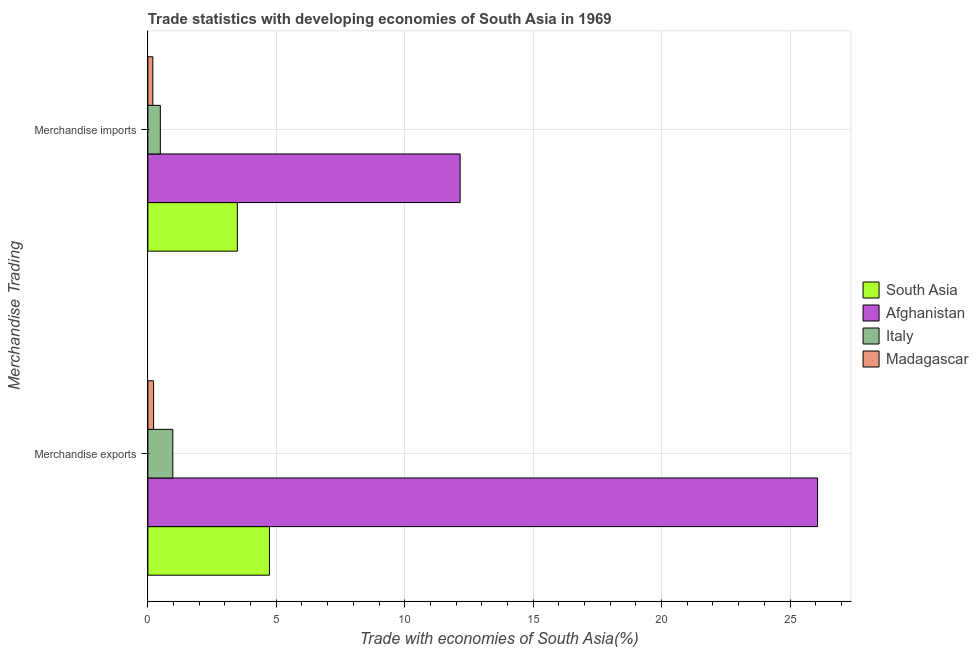How many groups of bars are there?
Your answer should be very brief. 2. Are the number of bars on each tick of the Y-axis equal?
Make the answer very short. Yes. What is the label of the 2nd group of bars from the top?
Offer a very short reply. Merchandise exports. What is the merchandise exports in Madagascar?
Give a very brief answer. 0.22. Across all countries, what is the maximum merchandise imports?
Provide a short and direct response. 12.16. Across all countries, what is the minimum merchandise exports?
Provide a short and direct response. 0.22. In which country was the merchandise imports maximum?
Offer a terse response. Afghanistan. In which country was the merchandise exports minimum?
Keep it short and to the point. Madagascar. What is the total merchandise imports in the graph?
Offer a terse response. 16.32. What is the difference between the merchandise exports in Afghanistan and that in Italy?
Provide a short and direct response. 25.1. What is the difference between the merchandise imports in Italy and the merchandise exports in South Asia?
Give a very brief answer. -4.25. What is the average merchandise exports per country?
Ensure brevity in your answer.  8. What is the difference between the merchandise exports and merchandise imports in Italy?
Keep it short and to the point. 0.49. In how many countries, is the merchandise exports greater than 2 %?
Make the answer very short. 2. What is the ratio of the merchandise imports in South Asia to that in Afghanistan?
Your answer should be very brief. 0.29. In how many countries, is the merchandise imports greater than the average merchandise imports taken over all countries?
Ensure brevity in your answer.  1. How many countries are there in the graph?
Your answer should be very brief. 4. Are the values on the major ticks of X-axis written in scientific E-notation?
Offer a terse response. No. Does the graph contain any zero values?
Offer a very short reply. No. Does the graph contain grids?
Your answer should be compact. Yes. How many legend labels are there?
Make the answer very short. 4. What is the title of the graph?
Offer a very short reply. Trade statistics with developing economies of South Asia in 1969. Does "Cabo Verde" appear as one of the legend labels in the graph?
Provide a succinct answer. No. What is the label or title of the X-axis?
Your answer should be compact. Trade with economies of South Asia(%). What is the label or title of the Y-axis?
Your answer should be compact. Merchandise Trading. What is the Trade with economies of South Asia(%) in South Asia in Merchandise exports?
Your answer should be compact. 4.73. What is the Trade with economies of South Asia(%) of Afghanistan in Merchandise exports?
Provide a succinct answer. 26.07. What is the Trade with economies of South Asia(%) of Italy in Merchandise exports?
Offer a very short reply. 0.97. What is the Trade with economies of South Asia(%) in Madagascar in Merchandise exports?
Keep it short and to the point. 0.22. What is the Trade with economies of South Asia(%) of South Asia in Merchandise imports?
Your response must be concise. 3.48. What is the Trade with economies of South Asia(%) of Afghanistan in Merchandise imports?
Make the answer very short. 12.16. What is the Trade with economies of South Asia(%) in Italy in Merchandise imports?
Ensure brevity in your answer.  0.48. What is the Trade with economies of South Asia(%) in Madagascar in Merchandise imports?
Make the answer very short. 0.19. Across all Merchandise Trading, what is the maximum Trade with economies of South Asia(%) in South Asia?
Give a very brief answer. 4.73. Across all Merchandise Trading, what is the maximum Trade with economies of South Asia(%) in Afghanistan?
Ensure brevity in your answer.  26.07. Across all Merchandise Trading, what is the maximum Trade with economies of South Asia(%) of Italy?
Ensure brevity in your answer.  0.97. Across all Merchandise Trading, what is the maximum Trade with economies of South Asia(%) of Madagascar?
Offer a very short reply. 0.22. Across all Merchandise Trading, what is the minimum Trade with economies of South Asia(%) of South Asia?
Keep it short and to the point. 3.48. Across all Merchandise Trading, what is the minimum Trade with economies of South Asia(%) of Afghanistan?
Offer a terse response. 12.16. Across all Merchandise Trading, what is the minimum Trade with economies of South Asia(%) in Italy?
Make the answer very short. 0.48. Across all Merchandise Trading, what is the minimum Trade with economies of South Asia(%) of Madagascar?
Your answer should be compact. 0.19. What is the total Trade with economies of South Asia(%) in South Asia in the graph?
Provide a succinct answer. 8.22. What is the total Trade with economies of South Asia(%) of Afghanistan in the graph?
Offer a very short reply. 38.23. What is the total Trade with economies of South Asia(%) in Italy in the graph?
Provide a short and direct response. 1.46. What is the total Trade with economies of South Asia(%) in Madagascar in the graph?
Provide a short and direct response. 0.42. What is the difference between the Trade with economies of South Asia(%) in South Asia in Merchandise exports and that in Merchandise imports?
Keep it short and to the point. 1.25. What is the difference between the Trade with economies of South Asia(%) of Afghanistan in Merchandise exports and that in Merchandise imports?
Offer a terse response. 13.92. What is the difference between the Trade with economies of South Asia(%) of Italy in Merchandise exports and that in Merchandise imports?
Your answer should be very brief. 0.49. What is the difference between the Trade with economies of South Asia(%) in Madagascar in Merchandise exports and that in Merchandise imports?
Offer a terse response. 0.03. What is the difference between the Trade with economies of South Asia(%) in South Asia in Merchandise exports and the Trade with economies of South Asia(%) in Afghanistan in Merchandise imports?
Your response must be concise. -7.42. What is the difference between the Trade with economies of South Asia(%) of South Asia in Merchandise exports and the Trade with economies of South Asia(%) of Italy in Merchandise imports?
Your answer should be very brief. 4.25. What is the difference between the Trade with economies of South Asia(%) of South Asia in Merchandise exports and the Trade with economies of South Asia(%) of Madagascar in Merchandise imports?
Keep it short and to the point. 4.54. What is the difference between the Trade with economies of South Asia(%) in Afghanistan in Merchandise exports and the Trade with economies of South Asia(%) in Italy in Merchandise imports?
Make the answer very short. 25.59. What is the difference between the Trade with economies of South Asia(%) of Afghanistan in Merchandise exports and the Trade with economies of South Asia(%) of Madagascar in Merchandise imports?
Offer a very short reply. 25.88. What is the difference between the Trade with economies of South Asia(%) in Italy in Merchandise exports and the Trade with economies of South Asia(%) in Madagascar in Merchandise imports?
Your response must be concise. 0.78. What is the average Trade with economies of South Asia(%) of South Asia per Merchandise Trading?
Ensure brevity in your answer.  4.11. What is the average Trade with economies of South Asia(%) in Afghanistan per Merchandise Trading?
Keep it short and to the point. 19.12. What is the average Trade with economies of South Asia(%) in Italy per Merchandise Trading?
Offer a terse response. 0.73. What is the average Trade with economies of South Asia(%) in Madagascar per Merchandise Trading?
Keep it short and to the point. 0.21. What is the difference between the Trade with economies of South Asia(%) in South Asia and Trade with economies of South Asia(%) in Afghanistan in Merchandise exports?
Keep it short and to the point. -21.34. What is the difference between the Trade with economies of South Asia(%) in South Asia and Trade with economies of South Asia(%) in Italy in Merchandise exports?
Ensure brevity in your answer.  3.76. What is the difference between the Trade with economies of South Asia(%) of South Asia and Trade with economies of South Asia(%) of Madagascar in Merchandise exports?
Your answer should be very brief. 4.51. What is the difference between the Trade with economies of South Asia(%) of Afghanistan and Trade with economies of South Asia(%) of Italy in Merchandise exports?
Provide a succinct answer. 25.1. What is the difference between the Trade with economies of South Asia(%) of Afghanistan and Trade with economies of South Asia(%) of Madagascar in Merchandise exports?
Offer a very short reply. 25.85. What is the difference between the Trade with economies of South Asia(%) of Italy and Trade with economies of South Asia(%) of Madagascar in Merchandise exports?
Keep it short and to the point. 0.75. What is the difference between the Trade with economies of South Asia(%) of South Asia and Trade with economies of South Asia(%) of Afghanistan in Merchandise imports?
Provide a short and direct response. -8.67. What is the difference between the Trade with economies of South Asia(%) of South Asia and Trade with economies of South Asia(%) of Italy in Merchandise imports?
Your answer should be very brief. 3. What is the difference between the Trade with economies of South Asia(%) in South Asia and Trade with economies of South Asia(%) in Madagascar in Merchandise imports?
Keep it short and to the point. 3.29. What is the difference between the Trade with economies of South Asia(%) of Afghanistan and Trade with economies of South Asia(%) of Italy in Merchandise imports?
Your answer should be compact. 11.67. What is the difference between the Trade with economies of South Asia(%) in Afghanistan and Trade with economies of South Asia(%) in Madagascar in Merchandise imports?
Your answer should be very brief. 11.96. What is the difference between the Trade with economies of South Asia(%) of Italy and Trade with economies of South Asia(%) of Madagascar in Merchandise imports?
Provide a succinct answer. 0.29. What is the ratio of the Trade with economies of South Asia(%) of South Asia in Merchandise exports to that in Merchandise imports?
Provide a short and direct response. 1.36. What is the ratio of the Trade with economies of South Asia(%) in Afghanistan in Merchandise exports to that in Merchandise imports?
Make the answer very short. 2.14. What is the ratio of the Trade with economies of South Asia(%) in Italy in Merchandise exports to that in Merchandise imports?
Your answer should be very brief. 2. What is the ratio of the Trade with economies of South Asia(%) of Madagascar in Merchandise exports to that in Merchandise imports?
Offer a terse response. 1.15. What is the difference between the highest and the second highest Trade with economies of South Asia(%) of South Asia?
Your answer should be very brief. 1.25. What is the difference between the highest and the second highest Trade with economies of South Asia(%) in Afghanistan?
Offer a very short reply. 13.92. What is the difference between the highest and the second highest Trade with economies of South Asia(%) in Italy?
Give a very brief answer. 0.49. What is the difference between the highest and the second highest Trade with economies of South Asia(%) in Madagascar?
Provide a short and direct response. 0.03. What is the difference between the highest and the lowest Trade with economies of South Asia(%) in South Asia?
Ensure brevity in your answer.  1.25. What is the difference between the highest and the lowest Trade with economies of South Asia(%) in Afghanistan?
Offer a terse response. 13.92. What is the difference between the highest and the lowest Trade with economies of South Asia(%) of Italy?
Offer a very short reply. 0.49. What is the difference between the highest and the lowest Trade with economies of South Asia(%) of Madagascar?
Your response must be concise. 0.03. 